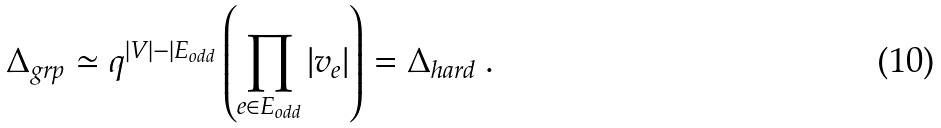Convert formula to latex. <formula><loc_0><loc_0><loc_500><loc_500>\Delta _ { g r p } \simeq q ^ { | V | - | E _ { o d d } } \left ( \prod _ { e \in E _ { o d d } } | v _ { e } | \right ) = \Delta _ { h a r d } \ .</formula> 